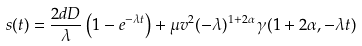Convert formula to latex. <formula><loc_0><loc_0><loc_500><loc_500>s ( t ) = \frac { 2 d D } { \lambda } \left ( 1 - e ^ { - \lambda t } \right ) + \mu v ^ { 2 } ( - \lambda ) ^ { 1 + 2 \alpha } \, \gamma ( 1 + 2 \alpha , - \lambda t )</formula> 